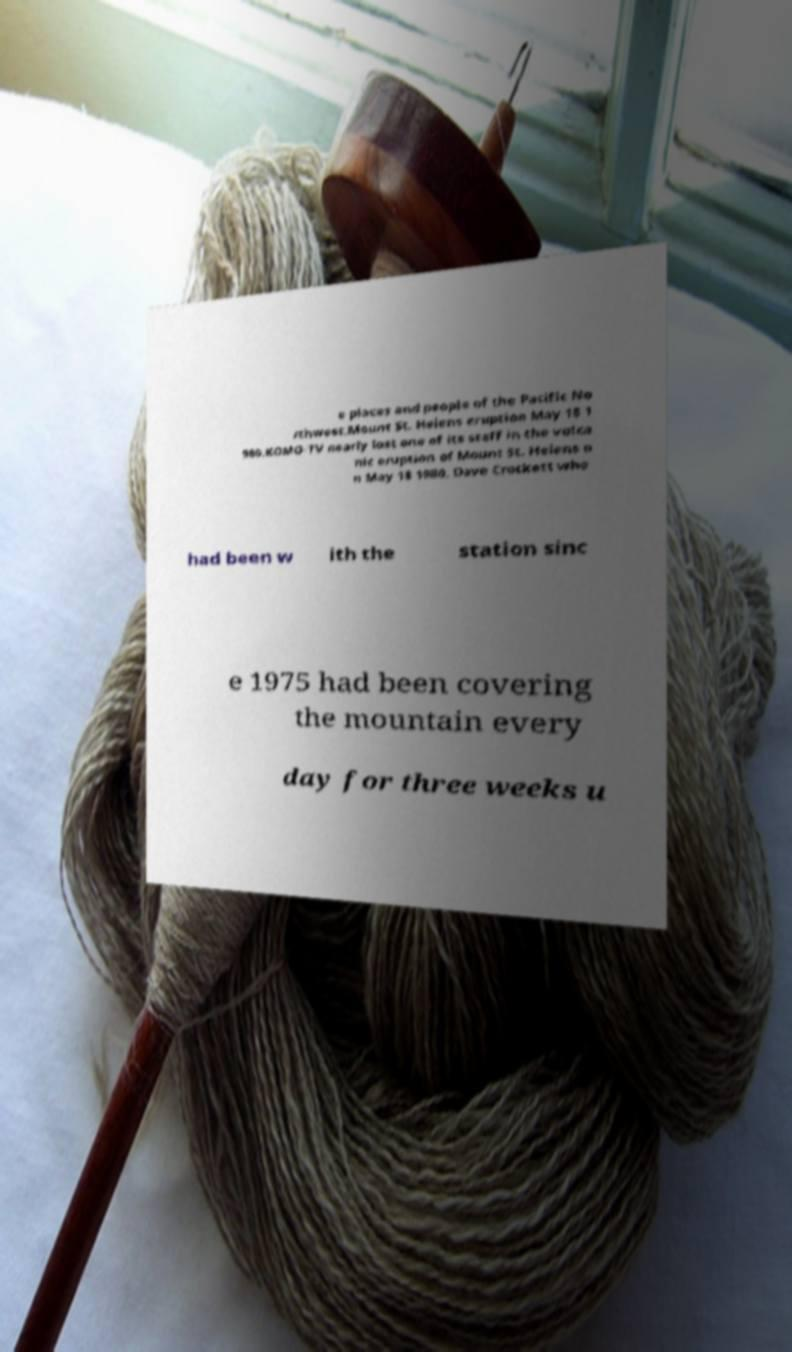For documentation purposes, I need the text within this image transcribed. Could you provide that? e places and people of the Pacific No rthwest.Mount St. Helens eruption May 18 1 980.KOMO-TV nearly lost one of its staff in the volca nic eruption of Mount St. Helens o n May 18 1980. Dave Crockett who had been w ith the station sinc e 1975 had been covering the mountain every day for three weeks u 